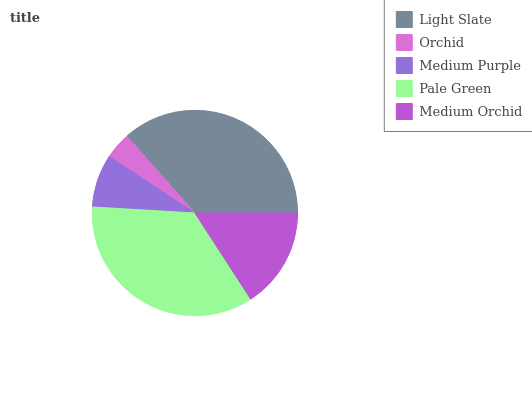Is Orchid the minimum?
Answer yes or no. Yes. Is Light Slate the maximum?
Answer yes or no. Yes. Is Medium Purple the minimum?
Answer yes or no. No. Is Medium Purple the maximum?
Answer yes or no. No. Is Medium Purple greater than Orchid?
Answer yes or no. Yes. Is Orchid less than Medium Purple?
Answer yes or no. Yes. Is Orchid greater than Medium Purple?
Answer yes or no. No. Is Medium Purple less than Orchid?
Answer yes or no. No. Is Medium Orchid the high median?
Answer yes or no. Yes. Is Medium Orchid the low median?
Answer yes or no. Yes. Is Medium Purple the high median?
Answer yes or no. No. Is Medium Purple the low median?
Answer yes or no. No. 